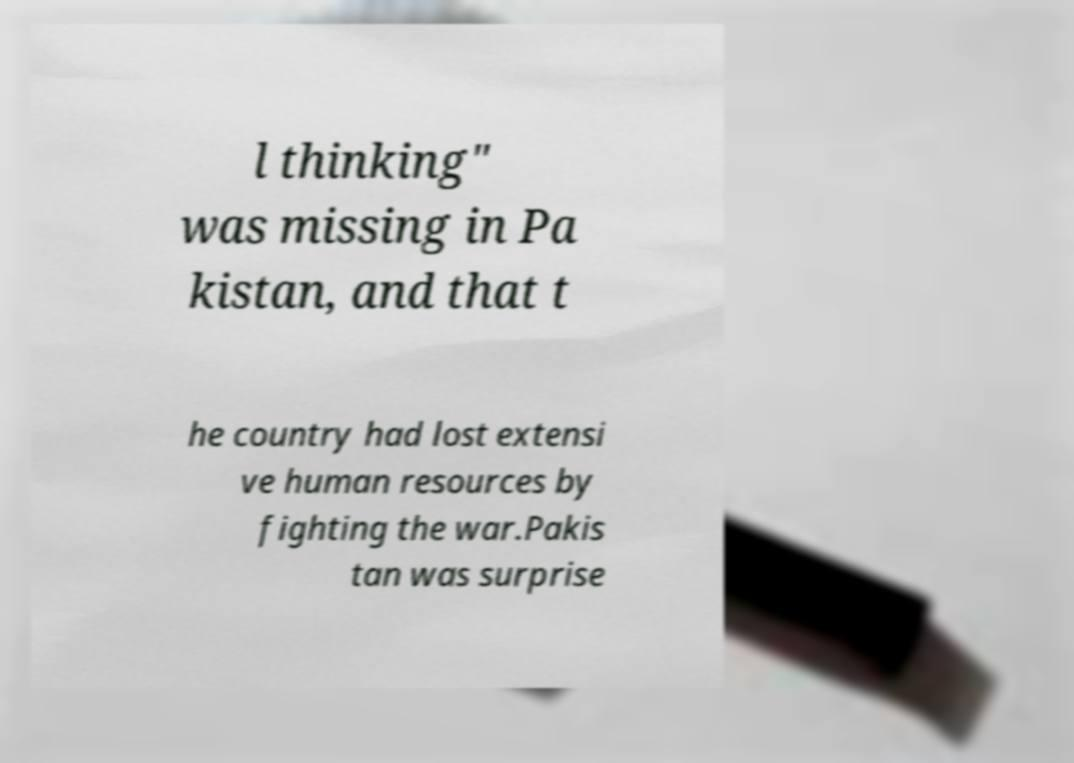Can you read and provide the text displayed in the image?This photo seems to have some interesting text. Can you extract and type it out for me? l thinking" was missing in Pa kistan, and that t he country had lost extensi ve human resources by fighting the war.Pakis tan was surprise 